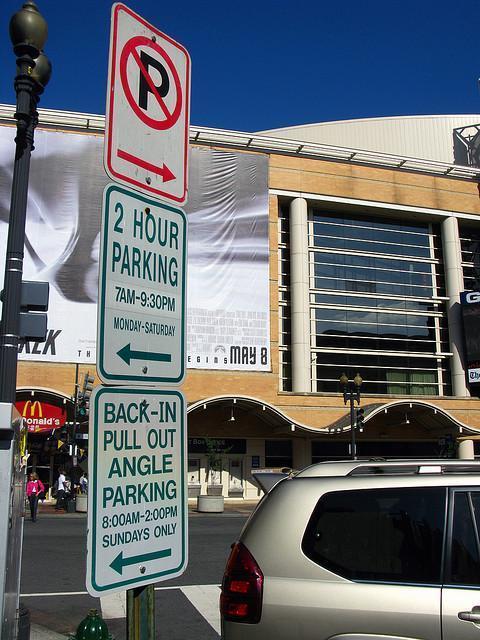How many hours can a person park for?
Give a very brief answer. 2. How many giraffes have visible legs?
Give a very brief answer. 0. 